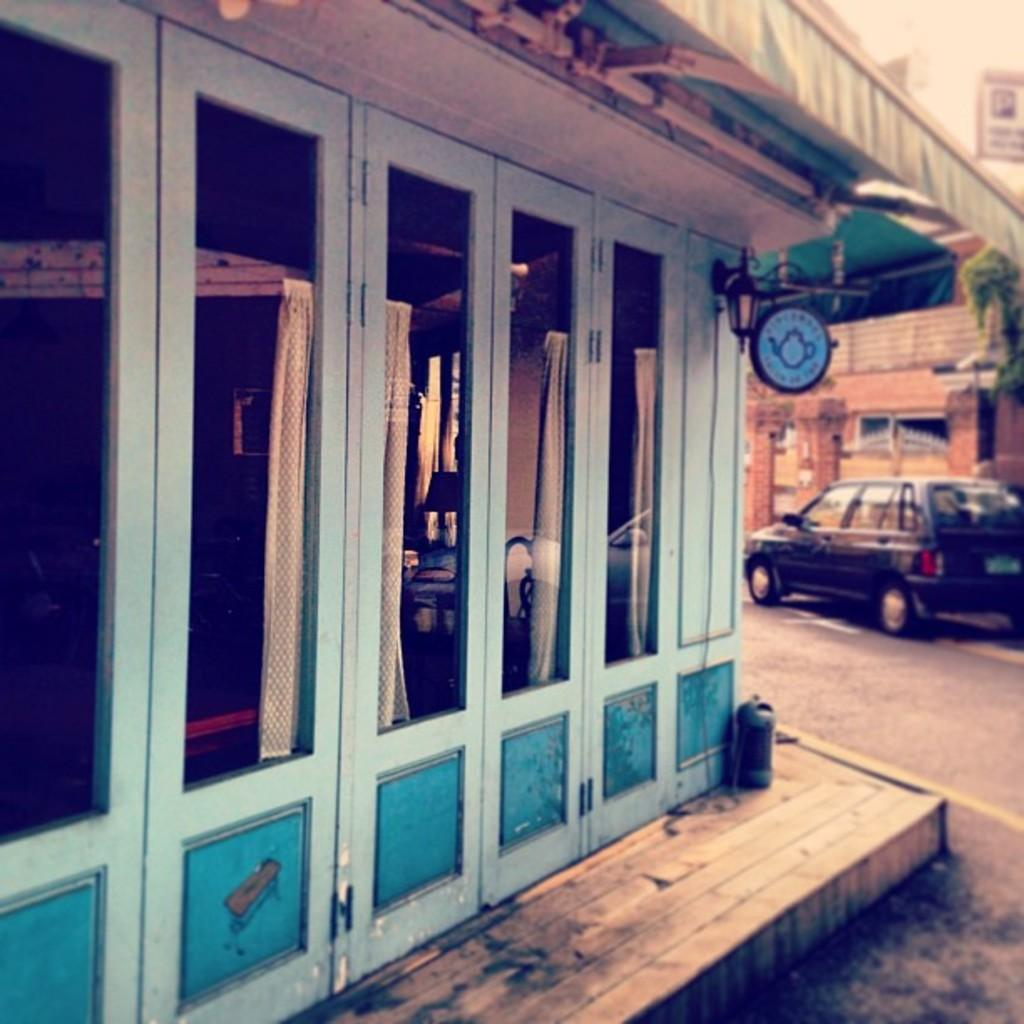What type of structures can be seen in the image? There are buildings in the image. What is on the road in the image? There is a vehicle on the road in the image. What type of material is used for the windows in the image? The image contains glass windows. What type of window treatment is present in the image? The image includes curtains. How would you describe the background of the image? The background of the image is blurred. What time of day is the image capturing, and how is it indicated by the presence of an hour? There is no hour present in the image, and the time of day cannot be determined from the provided facts. What type of hook is used to hang the curtains in the image? There is no hook visible in the image, and the method of hanging the curtains is not mentioned in the provided facts. 